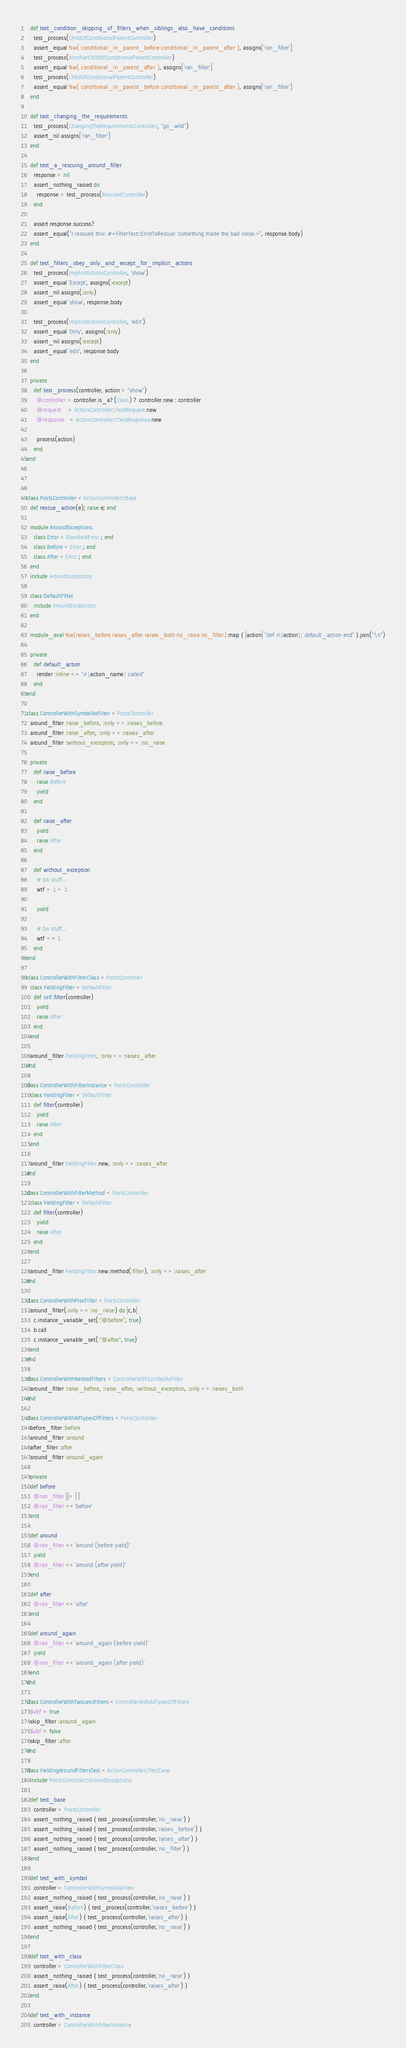Convert code to text. <code><loc_0><loc_0><loc_500><loc_500><_Ruby_>
  def test_condition_skipping_of_filters_when_siblings_also_have_conditions
    test_process(ChildOfConditionalParentController)
    assert_equal %w( conditional_in_parent_before conditional_in_parent_after ), assigns['ran_filter']
    test_process(AnotherChildOfConditionalParentController)
    assert_equal %w( conditional_in_parent_after ), assigns['ran_filter']
    test_process(ChildOfConditionalParentController)
    assert_equal %w( conditional_in_parent_before conditional_in_parent_after ), assigns['ran_filter']
  end

  def test_changing_the_requirements
    test_process(ChangingTheRequirementsController, "go_wild")
    assert_nil assigns['ran_filter']
  end

  def test_a_rescuing_around_filter
    response = nil
    assert_nothing_raised do
      response = test_process(RescuedController)
    end

    assert response.success?
    assert_equal("I rescued this: #<FilterTest::ErrorToRescue: Something made the bad noise.>", response.body)
  end

  def test_filters_obey_only_and_except_for_implicit_actions
    test_process(ImplicitActionsController, 'show')
    assert_equal 'Except', assigns(:except)
    assert_nil assigns(:only)
    assert_equal 'show', response.body

    test_process(ImplicitActionsController, 'edit')
    assert_equal 'Only', assigns(:only)
    assert_nil assigns(:except)
    assert_equal 'edit', response.body
  end

  private
    def test_process(controller, action = "show")
      @controller = controller.is_a?(Class) ? controller.new : controller
      @request    = ActionController::TestRequest.new
      @response   = ActionController::TestResponse.new

      process(action)
    end
end



class PostsController < ActionController::Base
  def rescue_action(e); raise e; end

  module AroundExceptions
    class Error < StandardError ; end
    class Before < Error ; end
    class After < Error ; end
  end
  include AroundExceptions

  class DefaultFilter
    include AroundExceptions
  end

  module_eval %w(raises_before raises_after raises_both no_raise no_filter).map { |action| "def #{action}; default_action end" }.join("\n")

  private
    def default_action
      render :inline => "#{action_name} called"
    end
end

class ControllerWithSymbolAsFilter < PostsController
  around_filter :raise_before, :only => :raises_before
  around_filter :raise_after, :only => :raises_after
  around_filter :without_exception, :only => :no_raise

  private
    def raise_before
      raise Before
      yield
    end

    def raise_after
      yield
      raise After
    end

    def without_exception
      # Do stuff...
      wtf = 1 + 1

      yield

      # Do stuff...
      wtf += 1
    end
end

class ControllerWithFilterClass < PostsController
  class YieldingFilter < DefaultFilter
    def self.filter(controller)
      yield
      raise After
    end
  end

  around_filter YieldingFilter, :only => :raises_after
end

class ControllerWithFilterInstance < PostsController
  class YieldingFilter < DefaultFilter
    def filter(controller)
      yield
      raise After
    end
  end

  around_filter YieldingFilter.new, :only => :raises_after
end

class ControllerWithFilterMethod < PostsController
  class YieldingFilter < DefaultFilter
    def filter(controller)
      yield
      raise After
    end
  end

  around_filter YieldingFilter.new.method(:filter), :only => :raises_after
end

class ControllerWithProcFilter < PostsController
  around_filter(:only => :no_raise) do |c,b|
    c.instance_variable_set(:"@before", true)
    b.call
    c.instance_variable_set(:"@after", true)
  end
end

class ControllerWithNestedFilters < ControllerWithSymbolAsFilter
  around_filter :raise_before, :raise_after, :without_exception, :only => :raises_both
end

class ControllerWithAllTypesOfFilters < PostsController
  before_filter :before
  around_filter :around
  after_filter :after
  around_filter :around_again

  private
  def before
    @ran_filter ||= []
    @ran_filter << 'before'
  end

  def around
    @ran_filter << 'around (before yield)'
    yield
    @ran_filter << 'around (after yield)'
  end

  def after
    @ran_filter << 'after'
  end

  def around_again
    @ran_filter << 'around_again (before yield)'
    yield
    @ran_filter << 'around_again (after yield)'
  end
end

class ControllerWithTwoLessFilters < ControllerWithAllTypesOfFilters
  $vbf = true
  skip_filter :around_again
  $vbf = false
  skip_filter :after
end

class YieldingAroundFiltersTest < ActionController::TestCase
  include PostsController::AroundExceptions

  def test_base
    controller = PostsController
    assert_nothing_raised { test_process(controller,'no_raise') }
    assert_nothing_raised { test_process(controller,'raises_before') }
    assert_nothing_raised { test_process(controller,'raises_after') }
    assert_nothing_raised { test_process(controller,'no_filter') }
  end

  def test_with_symbol
    controller = ControllerWithSymbolAsFilter
    assert_nothing_raised { test_process(controller,'no_raise') }
    assert_raise(Before) { test_process(controller,'raises_before') }
    assert_raise(After) { test_process(controller,'raises_after') }
    assert_nothing_raised { test_process(controller,'no_raise') }
  end

  def test_with_class
    controller = ControllerWithFilterClass
    assert_nothing_raised { test_process(controller,'no_raise') }
    assert_raise(After) { test_process(controller,'raises_after') }
  end

  def test_with_instance
    controller = ControllerWithFilterInstance</code> 